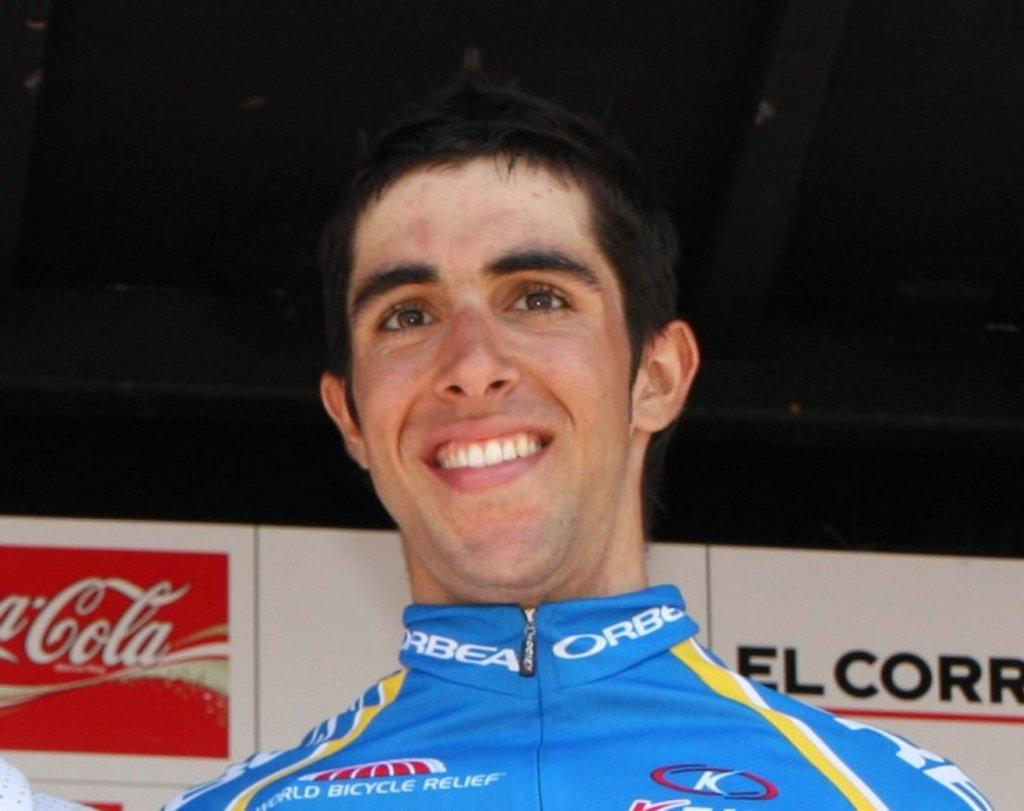<image>
Write a terse but informative summary of the picture. A man wearing a World Bicycle Relief shirt with the word Orbea on the collar poses in front of a Coca Cola advertisement. 